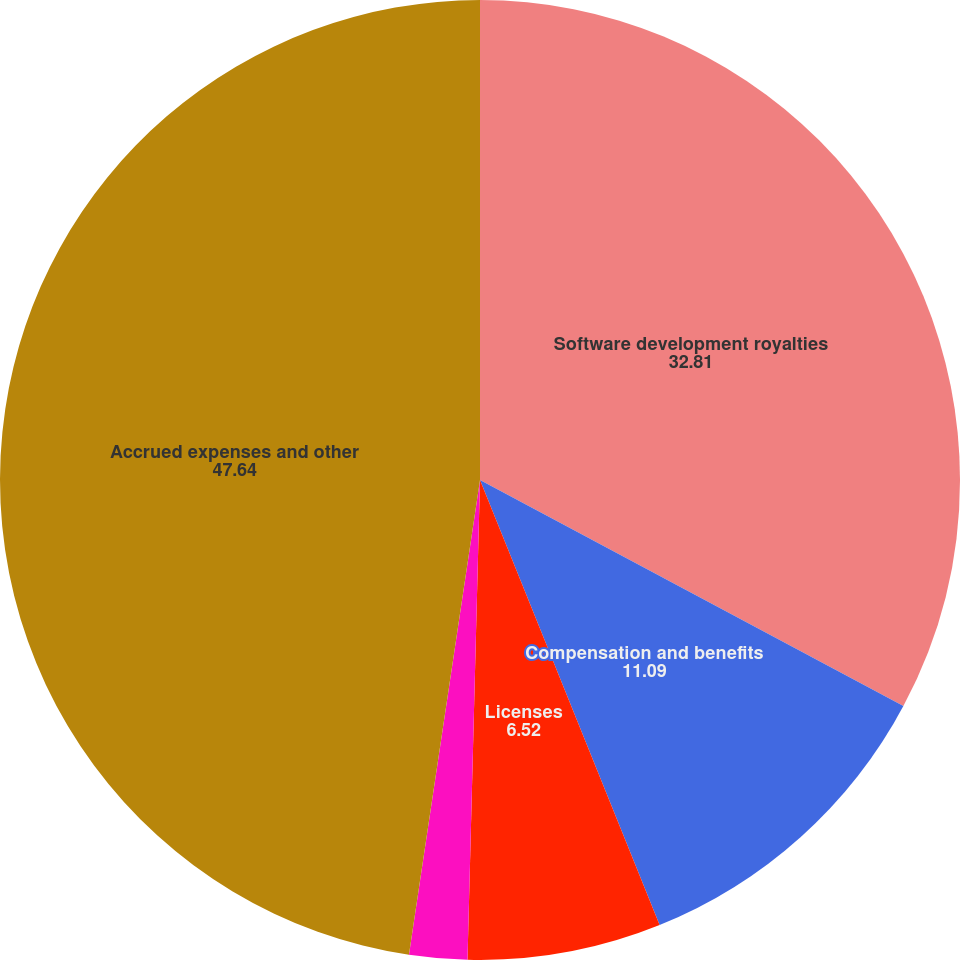Convert chart to OTSL. <chart><loc_0><loc_0><loc_500><loc_500><pie_chart><fcel>Software development royalties<fcel>Compensation and benefits<fcel>Licenses<fcel>Marketing and promotions<fcel>Accrued expenses and other<nl><fcel>32.81%<fcel>11.09%<fcel>6.52%<fcel>1.95%<fcel>47.64%<nl></chart> 